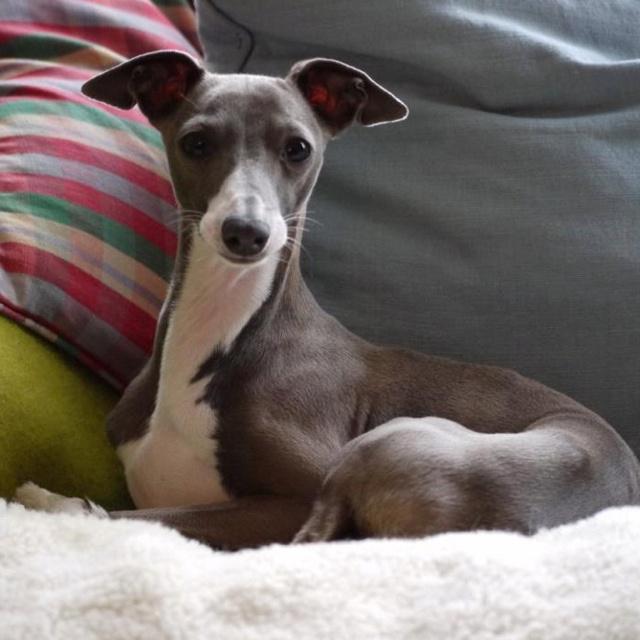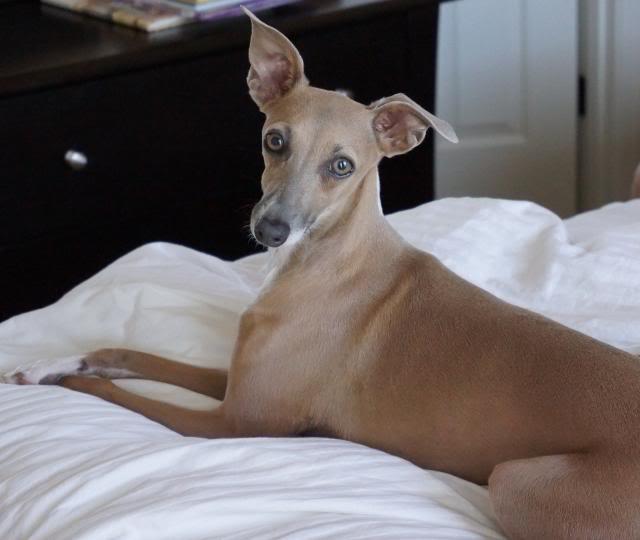The first image is the image on the left, the second image is the image on the right. Examine the images to the left and right. Is the description "Two dogs are sitting next to each other in the image on the right." accurate? Answer yes or no. No. The first image is the image on the left, the second image is the image on the right. For the images displayed, is the sentence "The right image contains twice as many hound dogs as the left image." factually correct? Answer yes or no. No. 